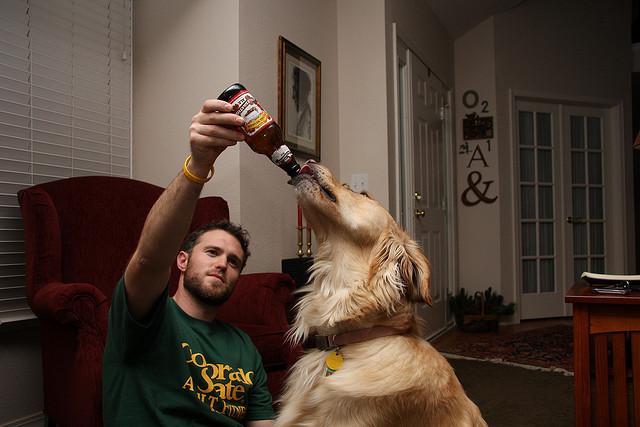Does the dog appear to like the beer?
Write a very short answer. Yes. What are they doing to the animal in the photo?
Answer briefly. Giving beer. Is this a full grown dog?
Keep it brief. Yes. Is this dog neglected?
Give a very brief answer. No. What is the dog holding?
Concise answer only. Bottle. What is the person riding beside the animal?
Be succinct. Nothing. What day is it?
Be succinct. Monday. What is the dog drinking?
Short answer required. Beer. Does the animal look like this is painful?
Give a very brief answer. No. What color is the dog?
Keep it brief. Brown. What is this person holding up?
Be succinct. Beer. Is this animal alive?
Answer briefly. Yes. 